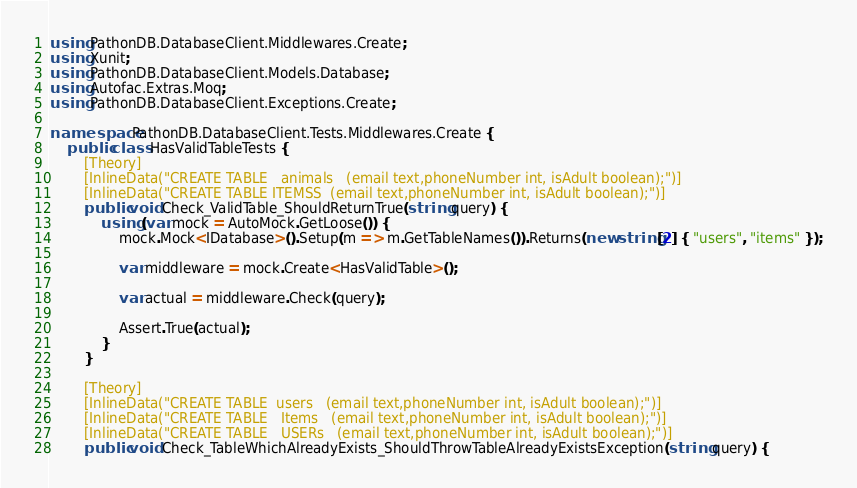<code> <loc_0><loc_0><loc_500><loc_500><_C#_>using PathonDB.DatabaseClient.Middlewares.Create;
using Xunit;
using PathonDB.DatabaseClient.Models.Database;
using Autofac.Extras.Moq;
using PathonDB.DatabaseClient.Exceptions.Create;

namespace PathonDB.DatabaseClient.Tests.Middlewares.Create {
    public class HasValidTableTests {
        [Theory]
        [InlineData("CREATE TABLE   animals   (email text,phoneNumber int, isAdult boolean);")]
        [InlineData("CREATE TABLE ITEMSS  (email text,phoneNumber int, isAdult boolean);")]
        public void Check_ValidTable_ShouldReturnTrue(string query) {
            using (var mock = AutoMock.GetLoose()) {
                mock.Mock<IDatabase>().Setup(m => m.GetTableNames()).Returns(new string[2] { "users", "items" });

                var middleware = mock.Create<HasValidTable>();

                var actual = middleware.Check(query);

                Assert.True(actual);
            }
        }

        [Theory]
        [InlineData("CREATE TABLE  users   (email text,phoneNumber int, isAdult boolean);")]
        [InlineData("CREATE TABLE   Items   (email text,phoneNumber int, isAdult boolean);")]
        [InlineData("CREATE TABLE   USERs   (email text,phoneNumber int, isAdult boolean);")]
        public void Check_TableWhichAlreadyExists_ShouldThrowTableAlreadyExistsException(string query) {</code> 